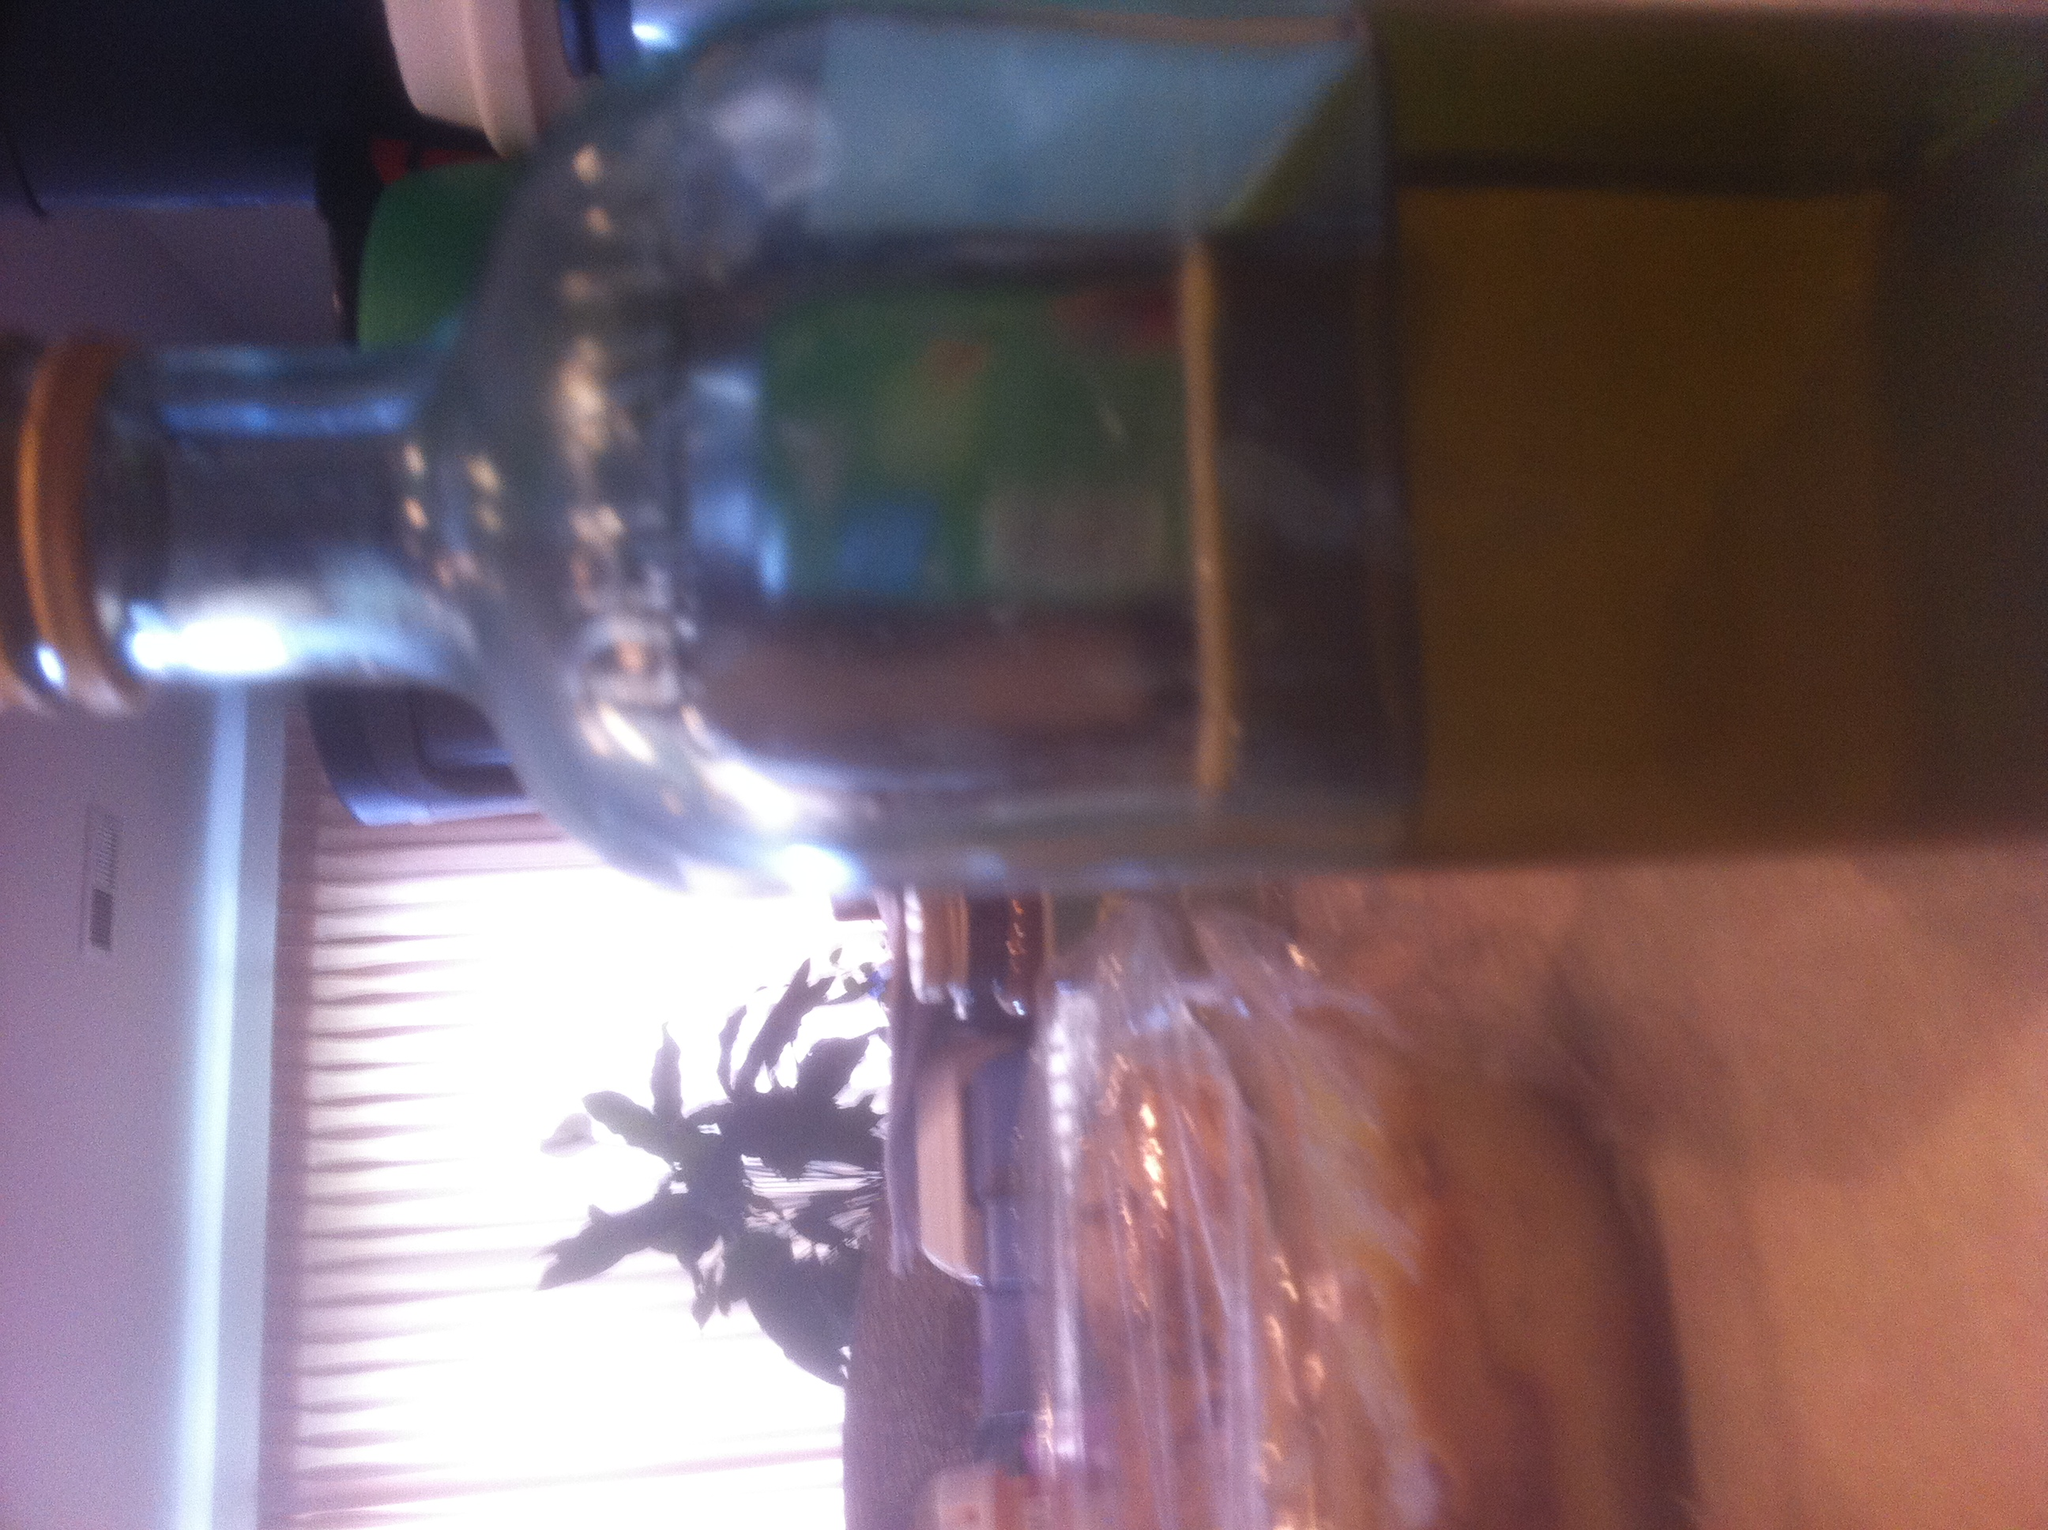Can you describe the setting of this image? The image seems to have been taken in an indoor environment, probably a kitchen or dining area. In the foreground, there's a glass bottle filled with a brownish or amber liquid. The background includes part of a table, some kitchen appliances or containers, and a window with blinds letting in natural light. The atmosphere appears warm and cozy, typical of a home setting. 